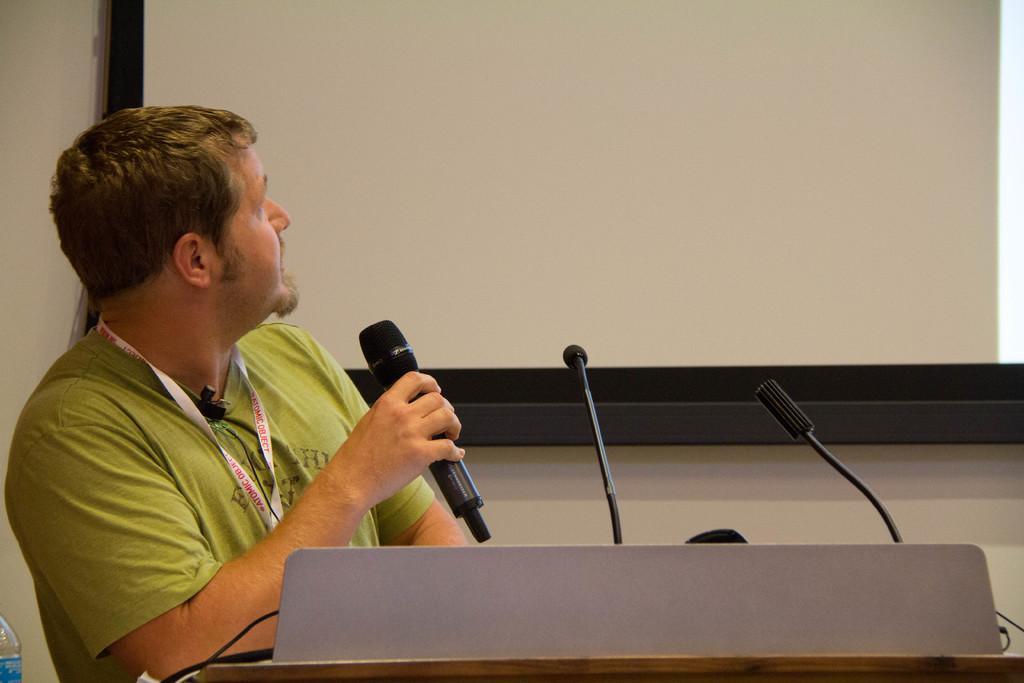Could you give a brief overview of what you see in this image? A man is holding microphone. This is bottle, wall and this is screen. 